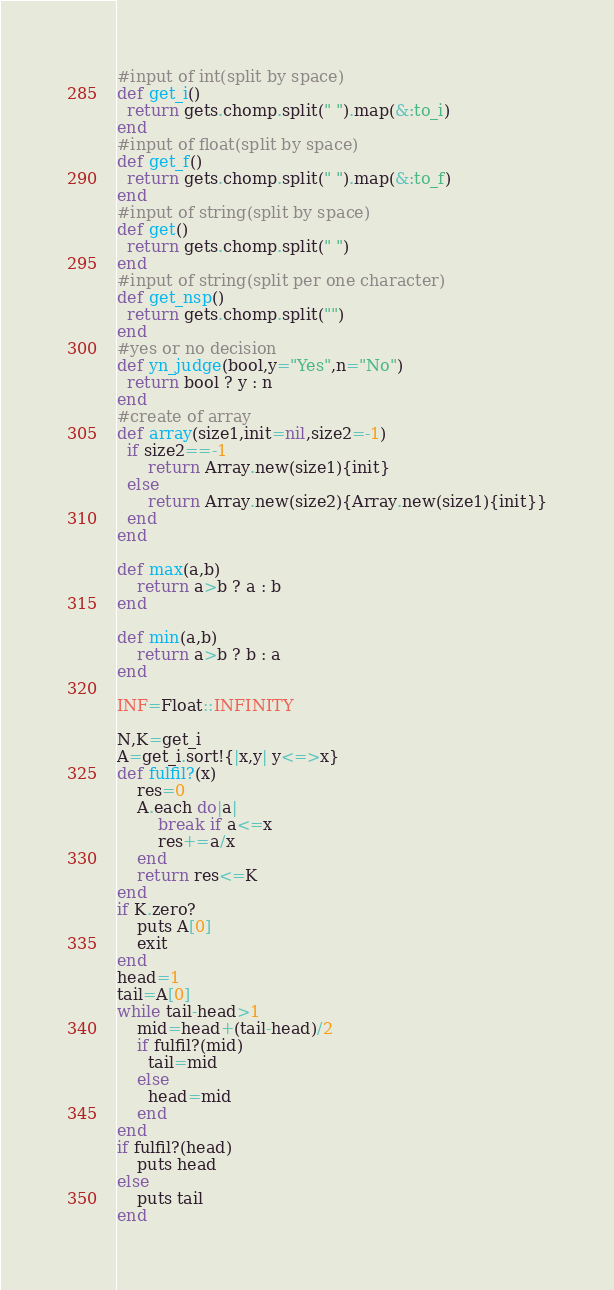<code> <loc_0><loc_0><loc_500><loc_500><_Ruby_>#input of int(split by space)
def get_i()
  return gets.chomp.split(" ").map(&:to_i)
end
#input of float(split by space)
def get_f()
  return gets.chomp.split(" ").map(&:to_f)
end
#input of string(split by space)
def get()
  return gets.chomp.split(" ")
end
#input of string(split per one character)
def get_nsp()
  return gets.chomp.split("")
end
#yes or no decision
def yn_judge(bool,y="Yes",n="No")
  return bool ? y : n 
end
#create of array
def array(size1,init=nil,size2=-1)
  if size2==-1
      return Array.new(size1){init}
  else
      return Array.new(size2){Array.new(size1){init}}
  end
end

def max(a,b)
    return a>b ? a : b
end

def min(a,b)
    return a>b ? b : a
end

INF=Float::INFINITY

N,K=get_i
A=get_i.sort!{|x,y| y<=>x}
def fulfil?(x)
    res=0
    A.each do|a|
        break if a<=x
        res+=a/x
    end
    return res<=K
end
if K.zero?
    puts A[0]
    exit
end
head=1
tail=A[0]
while tail-head>1
    mid=head+(tail-head)/2
    if fulfil?(mid)
      tail=mid
    else
      head=mid
    end
end
if fulfil?(head)
    puts head
else
    puts tail
end</code> 